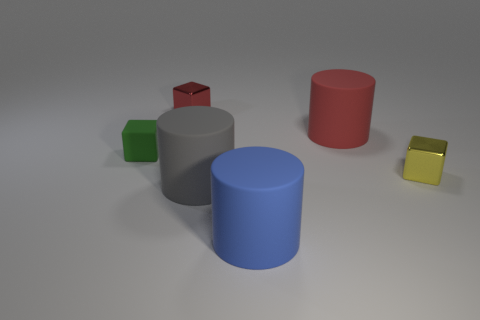What is the shape of the tiny thing that is behind the matte object on the left side of the small metallic cube that is on the left side of the small yellow shiny object?
Your answer should be very brief. Cube. Is the number of tiny yellow cubes behind the green rubber cube less than the number of tiny metallic objects that are to the left of the small yellow object?
Your response must be concise. Yes. Do the small metallic thing to the right of the blue matte cylinder and the green object that is on the left side of the red matte object have the same shape?
Your answer should be compact. Yes. There is a large red object left of the thing to the right of the large red thing; what shape is it?
Offer a terse response. Cylinder. Is there a small yellow thing made of the same material as the red cube?
Ensure brevity in your answer.  Yes. There is a large thing behind the tiny green rubber cube; what is its material?
Make the answer very short. Rubber. What is the material of the tiny green object?
Provide a succinct answer. Rubber. Are the large cylinder that is behind the green rubber cube and the red block made of the same material?
Keep it short and to the point. No. Is the number of yellow metallic cubes to the right of the yellow cube less than the number of tiny metallic cylinders?
Your answer should be very brief. No. The shiny block that is the same size as the yellow metal object is what color?
Give a very brief answer. Red. 